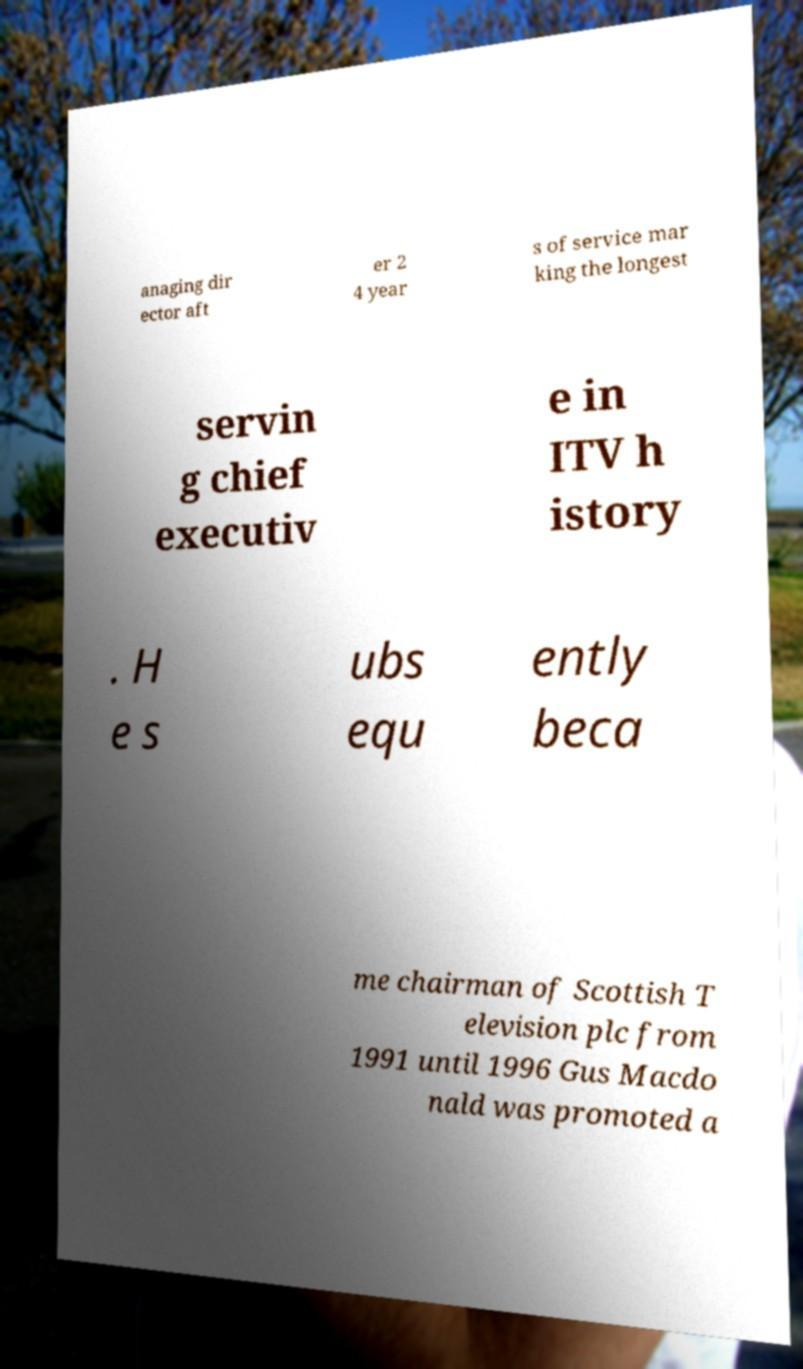Can you accurately transcribe the text from the provided image for me? anaging dir ector aft er 2 4 year s of service mar king the longest servin g chief executiv e in ITV h istory . H e s ubs equ ently beca me chairman of Scottish T elevision plc from 1991 until 1996 Gus Macdo nald was promoted a 